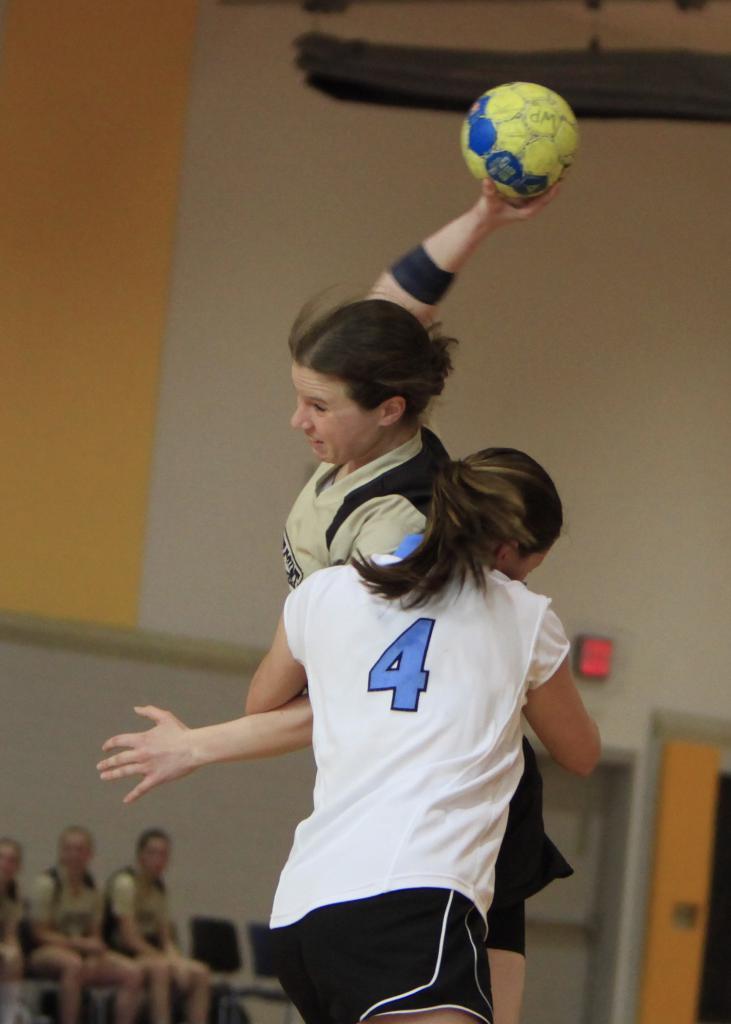What number does the player in the white shirt wear?
Offer a very short reply. 4. 